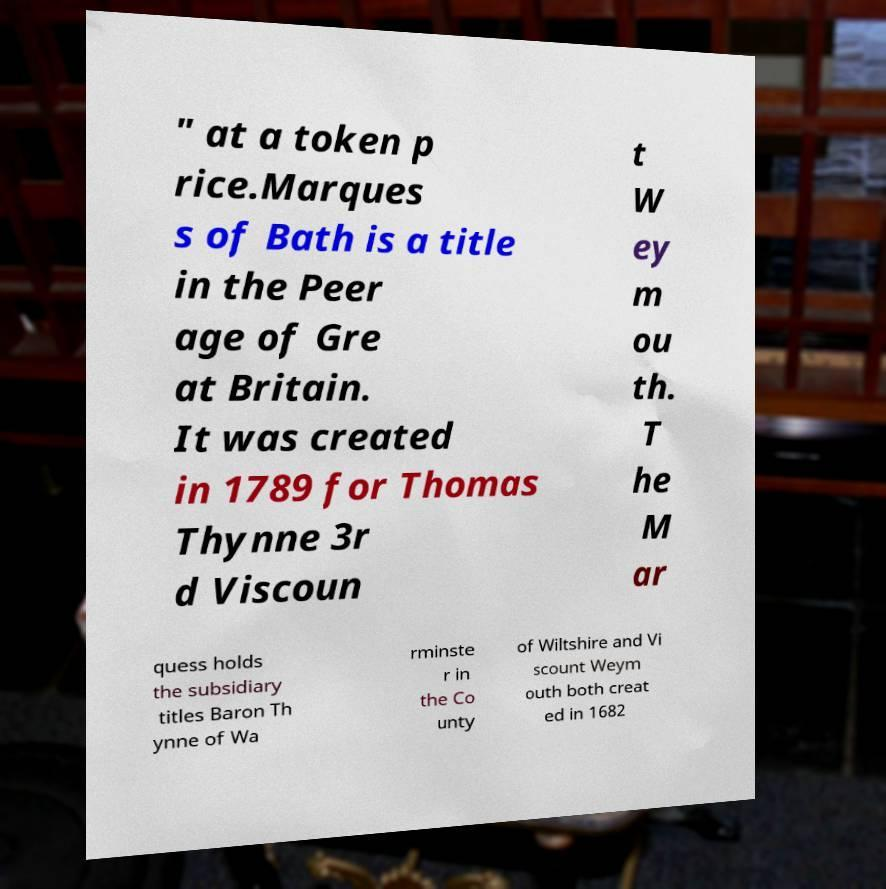Please identify and transcribe the text found in this image. " at a token p rice.Marques s of Bath is a title in the Peer age of Gre at Britain. It was created in 1789 for Thomas Thynne 3r d Viscoun t W ey m ou th. T he M ar quess holds the subsidiary titles Baron Th ynne of Wa rminste r in the Co unty of Wiltshire and Vi scount Weym outh both creat ed in 1682 